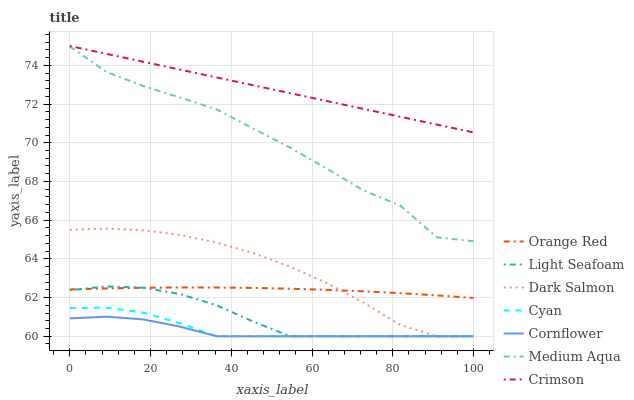Does Cornflower have the minimum area under the curve?
Answer yes or no. Yes. Does Crimson have the maximum area under the curve?
Answer yes or no. Yes. Does Dark Salmon have the minimum area under the curve?
Answer yes or no. No. Does Dark Salmon have the maximum area under the curve?
Answer yes or no. No. Is Crimson the smoothest?
Answer yes or no. Yes. Is Medium Aqua the roughest?
Answer yes or no. Yes. Is Dark Salmon the smoothest?
Answer yes or no. No. Is Dark Salmon the roughest?
Answer yes or no. No. Does Medium Aqua have the lowest value?
Answer yes or no. No. Does Crimson have the highest value?
Answer yes or no. Yes. Does Dark Salmon have the highest value?
Answer yes or no. No. Is Cornflower less than Medium Aqua?
Answer yes or no. Yes. Is Crimson greater than Dark Salmon?
Answer yes or no. Yes. Does Cornflower intersect Medium Aqua?
Answer yes or no. No. 